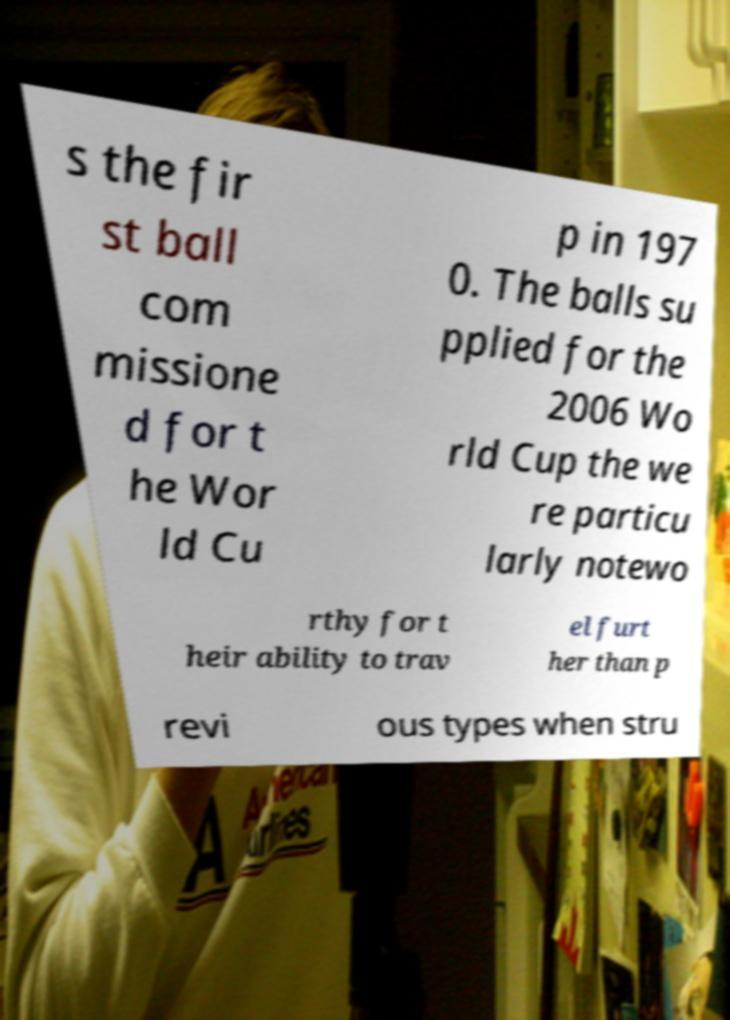I need the written content from this picture converted into text. Can you do that? s the fir st ball com missione d for t he Wor ld Cu p in 197 0. The balls su pplied for the 2006 Wo rld Cup the we re particu larly notewo rthy for t heir ability to trav el furt her than p revi ous types when stru 